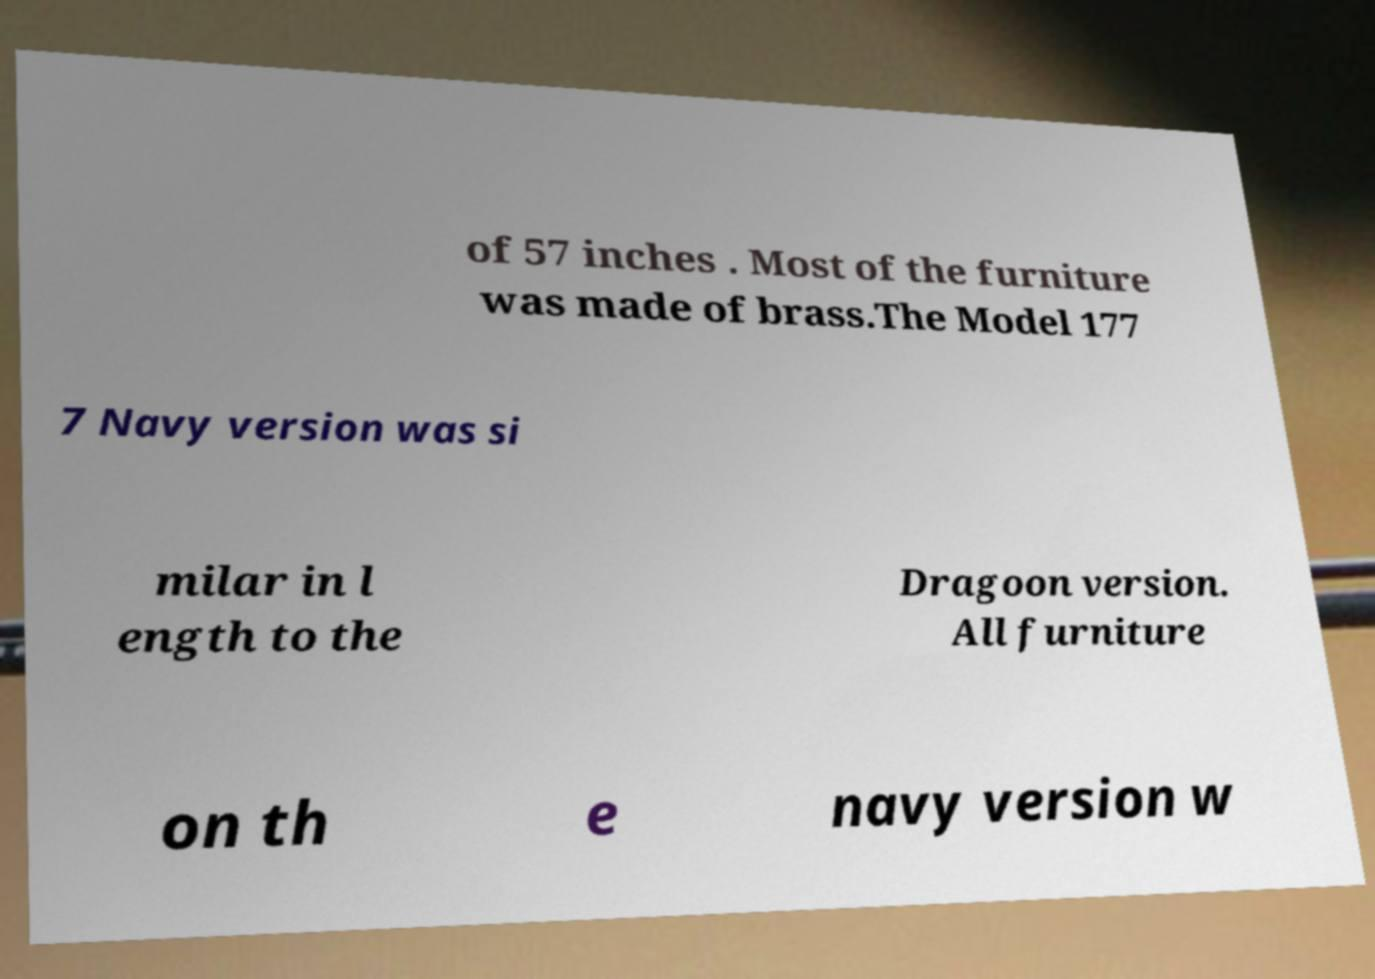I need the written content from this picture converted into text. Can you do that? of 57 inches . Most of the furniture was made of brass.The Model 177 7 Navy version was si milar in l ength to the Dragoon version. All furniture on th e navy version w 